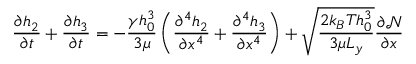<formula> <loc_0><loc_0><loc_500><loc_500>\frac { \partial h _ { 2 } } { \partial t } + \frac { \partial h _ { 3 } } { \partial t } = - \frac { \gamma h _ { 0 } ^ { 3 } } { 3 \mu } \left ( \frac { \partial ^ { 4 } h _ { 2 } } { \partial x ^ { 4 } } + \frac { \partial ^ { 4 } h _ { 3 } } { \partial x ^ { 4 } } \right ) + \sqrt { \frac { 2 k _ { B } T h _ { 0 } ^ { 3 } } { 3 \mu L _ { y } } } \frac { \partial \mathcal { N } } { \partial x }</formula> 